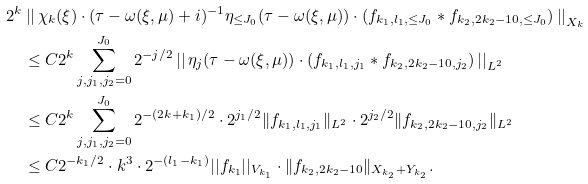<formula> <loc_0><loc_0><loc_500><loc_500>2 ^ { k } & \left | \right | \chi _ { k } ( \xi ) \cdot ( \tau - \omega ( \xi , \mu ) + i ) ^ { - 1 } \eta _ { \leq J _ { 0 } } ( \tau - \omega ( \xi , \mu ) ) \cdot ( f _ { k _ { 1 } , l _ { 1 } , \leq J _ { 0 } } \ast f _ { k _ { 2 } , 2 k _ { 2 } - 1 0 , \leq J _ { 0 } } ) \left | \right | _ { X _ { k } } \\ & \leq C 2 ^ { k } \sum _ { j , j _ { 1 } , j _ { 2 } = 0 } ^ { J _ { 0 } } 2 ^ { - j / 2 } \left | \right | \eta _ { j } ( \tau - \omega ( \xi , \mu ) ) \cdot ( f _ { k _ { 1 } , l _ { 1 } , j _ { 1 } } \ast f _ { k _ { 2 } , 2 k _ { 2 } - 1 0 , j _ { 2 } } ) \left | \right | _ { L ^ { 2 } } \\ & \leq C 2 ^ { k } \sum _ { j , j _ { 1 } , j _ { 2 } = 0 } ^ { J _ { 0 } } 2 ^ { - ( 2 k + k _ { 1 } ) / 2 } \cdot 2 ^ { j _ { 1 } / 2 } \| f _ { k _ { 1 } , l _ { 1 } , j _ { 1 } } \| _ { L ^ { 2 } } \cdot 2 ^ { j _ { 2 } / 2 } \| f _ { k _ { 2 } , 2 k _ { 2 } - 1 0 , j _ { 2 } } \| _ { L ^ { 2 } } \\ & \leq C 2 ^ { - k _ { 1 } / 2 } \cdot k ^ { 3 } \cdot 2 ^ { - ( l _ { 1 } - k _ { 1 } ) } | | f _ { k _ { 1 } } | | _ { V _ { k _ { 1 } } } \cdot \| f _ { k _ { 2 } , 2 k _ { 2 } - 1 0 } \| _ { X _ { k _ { 2 } } + Y _ { k _ { 2 } } } .</formula> 